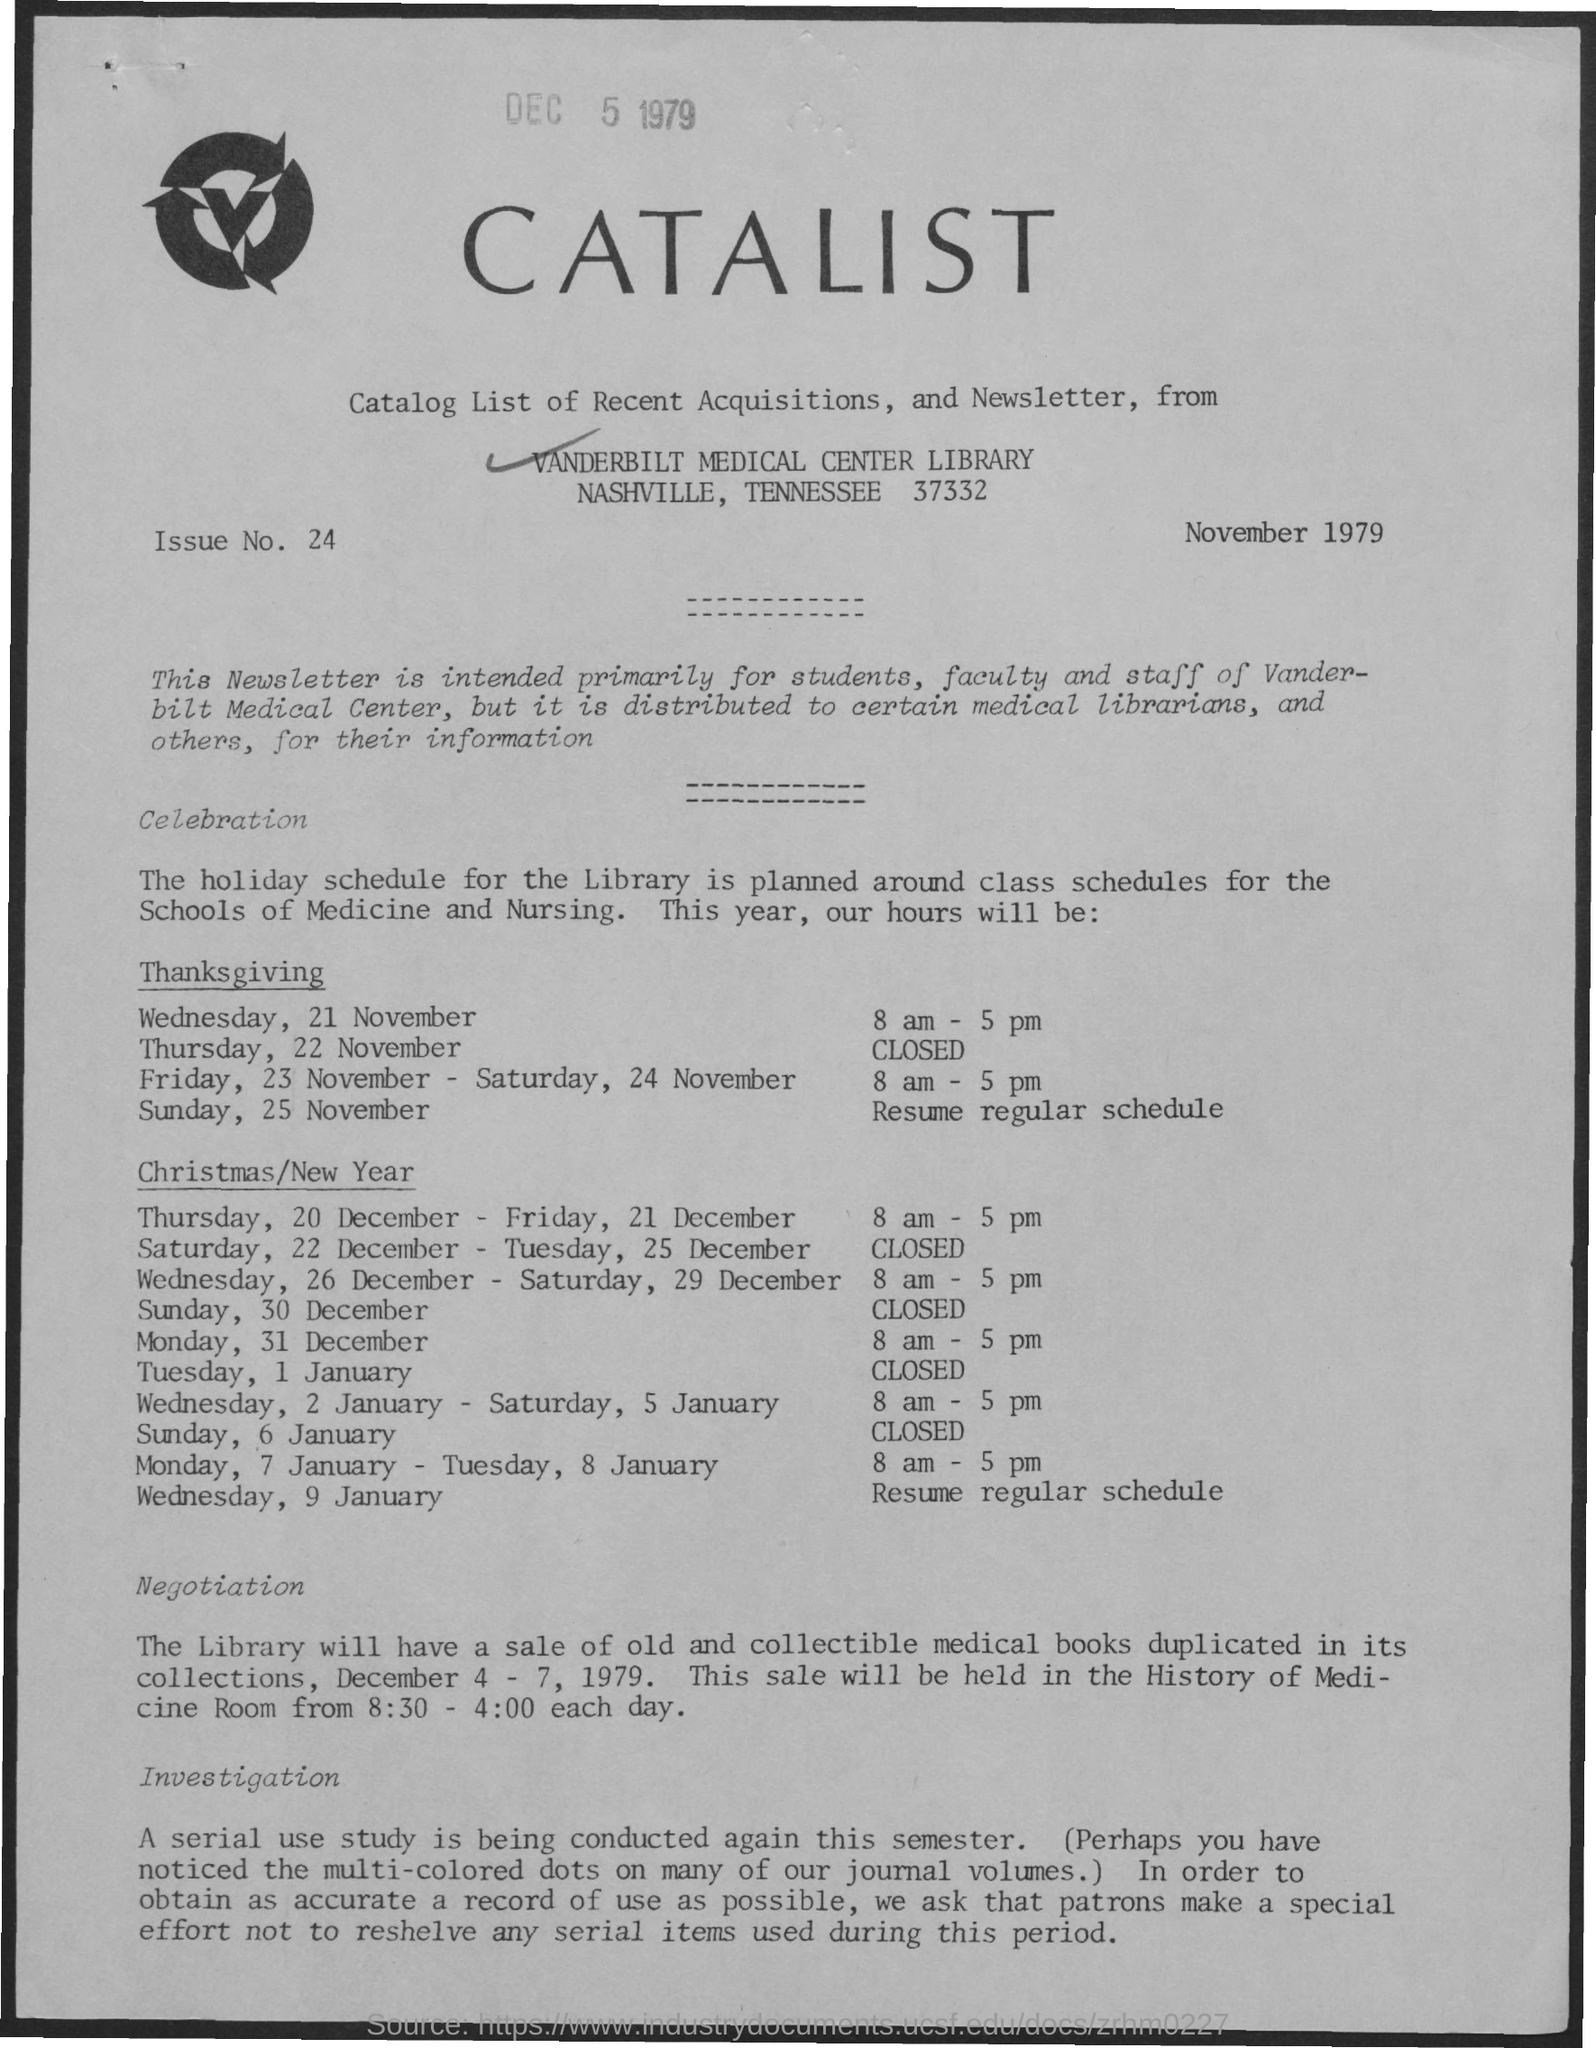What is the Issue No. given in the document?
Offer a terse response. 24. What is the document dated?
Your response must be concise. November 1979. 